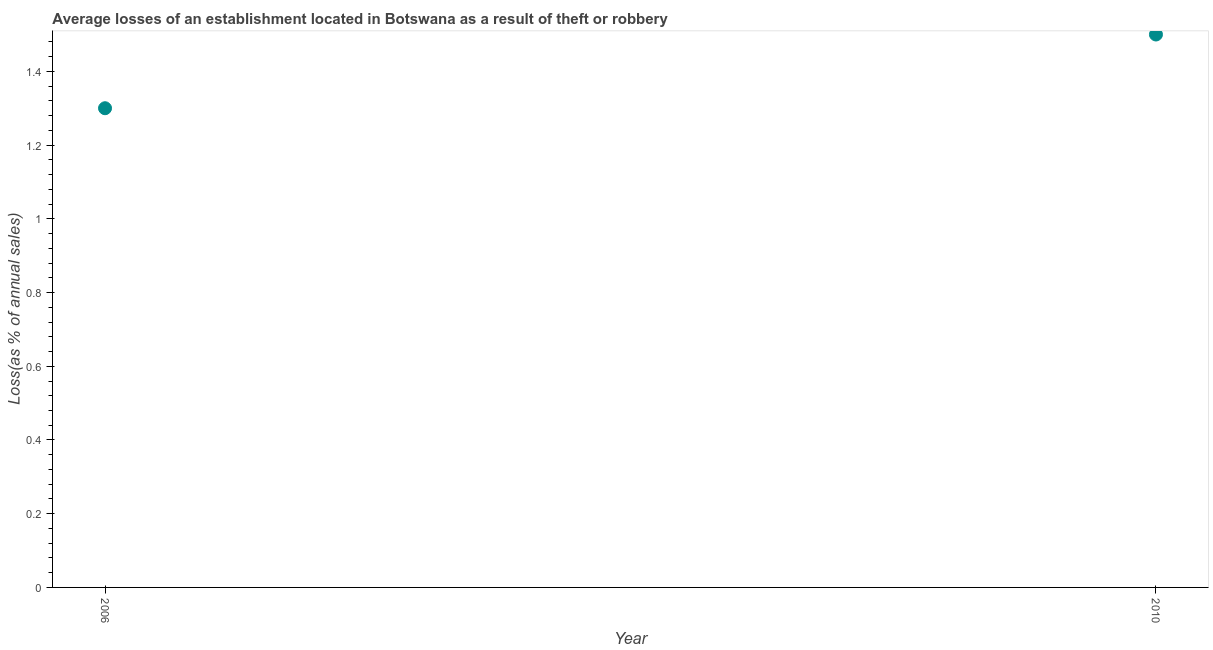In which year was the losses due to theft maximum?
Give a very brief answer. 2010. In which year was the losses due to theft minimum?
Offer a terse response. 2006. What is the difference between the losses due to theft in 2006 and 2010?
Provide a succinct answer. -0.2. What is the average losses due to theft per year?
Offer a very short reply. 1.4. What is the median losses due to theft?
Offer a very short reply. 1.4. In how many years, is the losses due to theft greater than 0.88 %?
Provide a succinct answer. 2. Do a majority of the years between 2006 and 2010 (inclusive) have losses due to theft greater than 0.6000000000000001 %?
Keep it short and to the point. Yes. What is the ratio of the losses due to theft in 2006 to that in 2010?
Your answer should be compact. 0.87. Is the losses due to theft in 2006 less than that in 2010?
Keep it short and to the point. Yes. Does the losses due to theft monotonically increase over the years?
Your answer should be very brief. Yes. How many dotlines are there?
Provide a succinct answer. 1. Are the values on the major ticks of Y-axis written in scientific E-notation?
Provide a short and direct response. No. Does the graph contain any zero values?
Your answer should be compact. No. What is the title of the graph?
Keep it short and to the point. Average losses of an establishment located in Botswana as a result of theft or robbery. What is the label or title of the Y-axis?
Provide a succinct answer. Loss(as % of annual sales). What is the Loss(as % of annual sales) in 2006?
Your response must be concise. 1.3. What is the ratio of the Loss(as % of annual sales) in 2006 to that in 2010?
Provide a short and direct response. 0.87. 